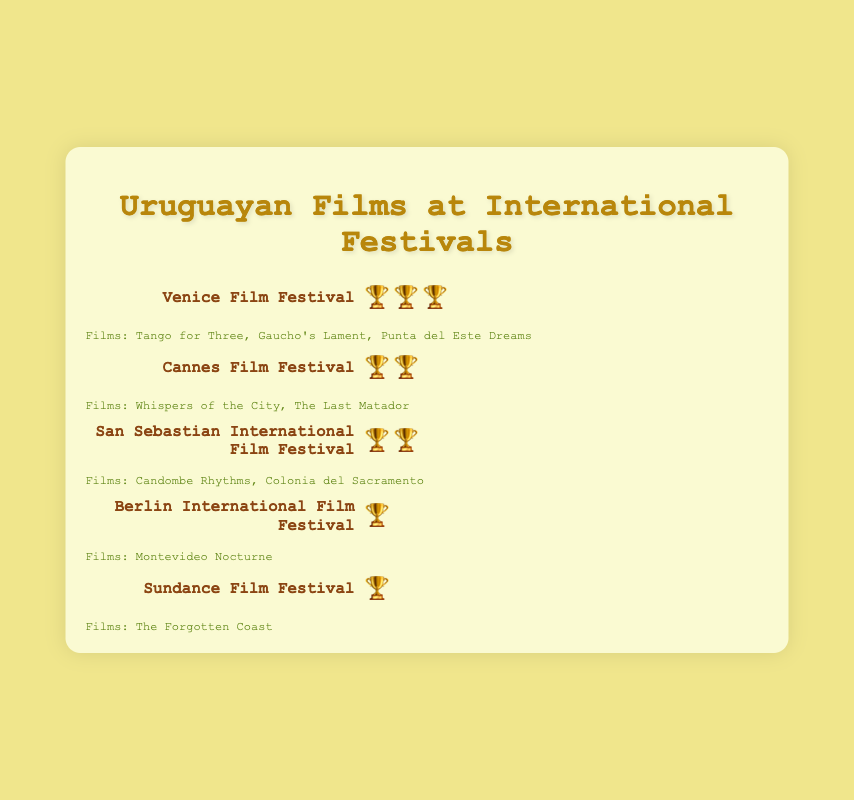Which festival features the film "Montevideo Nocturne"? Check the film names listed beside each festival and match "Montevideo Nocturne" to the corresponding festival.
Answer: Berlin International Film Festival How many trophies did the Venice Film Festival win? Count the number of trophy emojis (🏆) next to the Venice Film Festival entry.
Answer: 3 Which festivals have participated with exactly two films? Look at the list of films for each festival and identify those with exactly two films.
Answer: Cannes Film Festival, San Sebastian International Film Festival Sum all the trophies won across all festivals. Add up the number of trophy emojis from each festival.
Answer: 9 Which film festivals feature only one Uruguayan film each? Look at the list of films for each festival and identify those with only one film.
Answer: Berlin International Film Festival, Sundance Film Festival Which festival has the highest number of trophies? Compare the number of trophies among all festivals and identify the one with the most.
Answer: Venice Film Festival Out of the listed festivals, which one has "The Last Matador"? Check the films listed beside each festival and find the one that includes "The Last Matador".
Answer: Cannes Film Festival How many festivals have more than one trophy? Count the festivals where the number of trophies (🏆) is more than one.
Answer: 3 